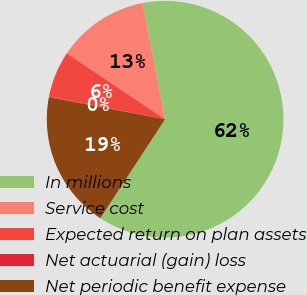Convert chart to OTSL. <chart><loc_0><loc_0><loc_500><loc_500><pie_chart><fcel>In millions<fcel>Service cost<fcel>Expected return on plan assets<fcel>Net actuarial (gain) loss<fcel>Net periodic benefit expense<nl><fcel>62.3%<fcel>12.54%<fcel>6.32%<fcel>0.1%<fcel>18.76%<nl></chart> 